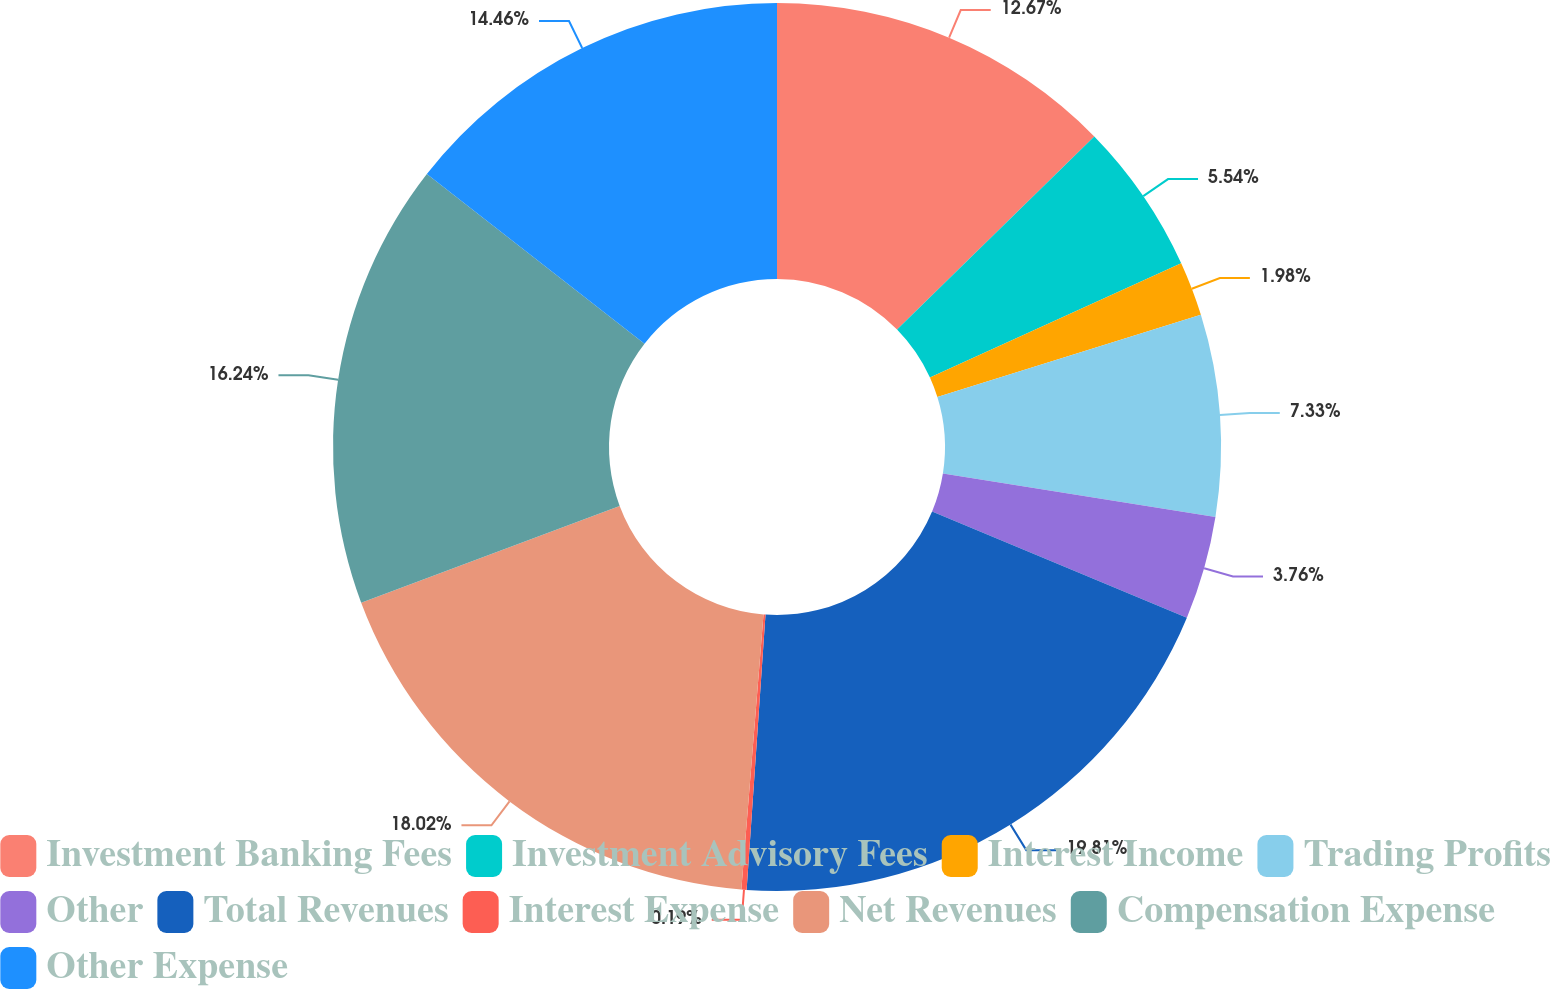<chart> <loc_0><loc_0><loc_500><loc_500><pie_chart><fcel>Investment Banking Fees<fcel>Investment Advisory Fees<fcel>Interest Income<fcel>Trading Profits<fcel>Other<fcel>Total Revenues<fcel>Interest Expense<fcel>Net Revenues<fcel>Compensation Expense<fcel>Other Expense<nl><fcel>12.67%<fcel>5.54%<fcel>1.98%<fcel>7.33%<fcel>3.76%<fcel>19.81%<fcel>0.19%<fcel>18.02%<fcel>16.24%<fcel>14.46%<nl></chart> 